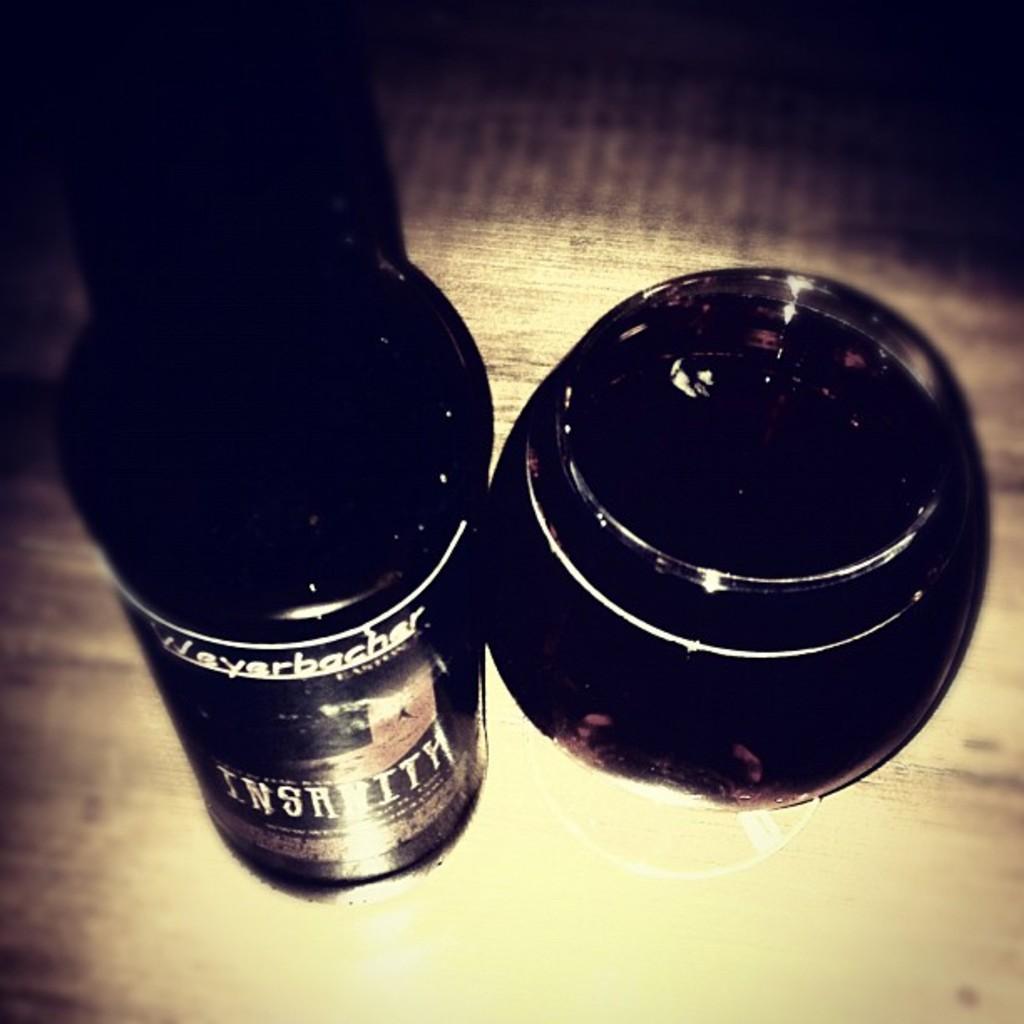Can you describe this image briefly? In the center of the image, we can see shoe polishers which are placed on the table. 